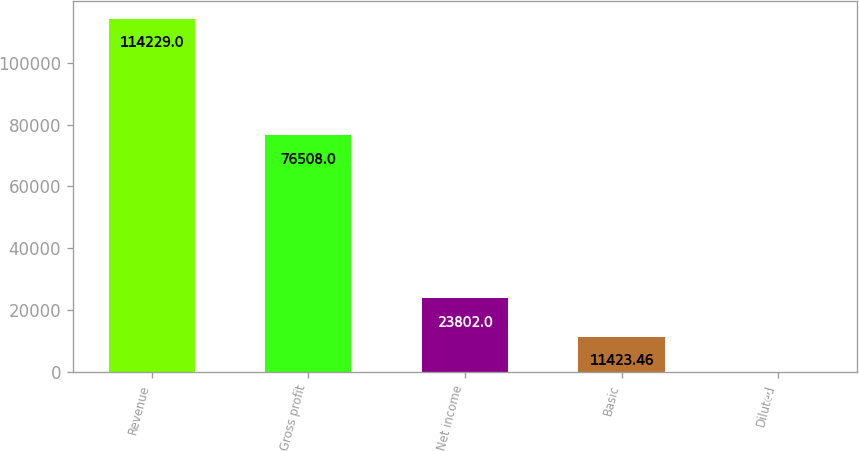Convert chart. <chart><loc_0><loc_0><loc_500><loc_500><bar_chart><fcel>Revenue<fcel>Gross profit<fcel>Net income<fcel>Basic<fcel>Diluted<nl><fcel>114229<fcel>76508<fcel>23802<fcel>11423.5<fcel>0.62<nl></chart> 